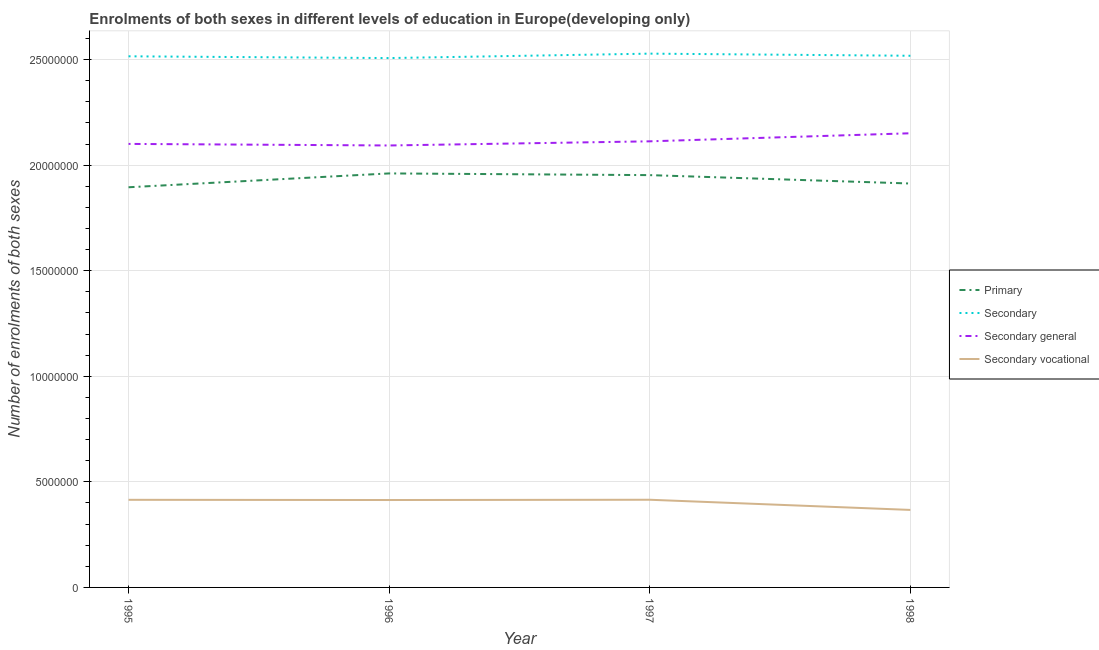How many different coloured lines are there?
Offer a terse response. 4. What is the number of enrolments in secondary education in 1998?
Keep it short and to the point. 2.52e+07. Across all years, what is the maximum number of enrolments in secondary education?
Your response must be concise. 2.53e+07. Across all years, what is the minimum number of enrolments in secondary education?
Offer a terse response. 2.51e+07. What is the total number of enrolments in secondary vocational education in the graph?
Offer a terse response. 1.61e+07. What is the difference between the number of enrolments in primary education in 1996 and that in 1997?
Provide a succinct answer. 8.08e+04. What is the difference between the number of enrolments in primary education in 1998 and the number of enrolments in secondary general education in 1995?
Your response must be concise. -1.88e+06. What is the average number of enrolments in primary education per year?
Your answer should be very brief. 1.93e+07. In the year 1995, what is the difference between the number of enrolments in secondary general education and number of enrolments in secondary education?
Your response must be concise. -4.15e+06. In how many years, is the number of enrolments in secondary general education greater than 15000000?
Your answer should be very brief. 4. What is the ratio of the number of enrolments in primary education in 1995 to that in 1997?
Keep it short and to the point. 0.97. Is the difference between the number of enrolments in secondary vocational education in 1996 and 1997 greater than the difference between the number of enrolments in primary education in 1996 and 1997?
Provide a short and direct response. No. What is the difference between the highest and the second highest number of enrolments in secondary general education?
Your answer should be compact. 3.82e+05. What is the difference between the highest and the lowest number of enrolments in primary education?
Offer a terse response. 6.56e+05. Does the number of enrolments in primary education monotonically increase over the years?
Make the answer very short. No. Is the number of enrolments in secondary vocational education strictly less than the number of enrolments in secondary education over the years?
Keep it short and to the point. Yes. How many years are there in the graph?
Give a very brief answer. 4. Are the values on the major ticks of Y-axis written in scientific E-notation?
Your answer should be compact. No. Does the graph contain any zero values?
Your response must be concise. No. Where does the legend appear in the graph?
Your response must be concise. Center right. How are the legend labels stacked?
Your answer should be very brief. Vertical. What is the title of the graph?
Offer a terse response. Enrolments of both sexes in different levels of education in Europe(developing only). Does "UNAIDS" appear as one of the legend labels in the graph?
Ensure brevity in your answer.  No. What is the label or title of the X-axis?
Provide a short and direct response. Year. What is the label or title of the Y-axis?
Provide a succinct answer. Number of enrolments of both sexes. What is the Number of enrolments of both sexes of Primary in 1995?
Your answer should be compact. 1.90e+07. What is the Number of enrolments of both sexes in Secondary in 1995?
Ensure brevity in your answer.  2.52e+07. What is the Number of enrolments of both sexes in Secondary general in 1995?
Give a very brief answer. 2.10e+07. What is the Number of enrolments of both sexes in Secondary vocational in 1995?
Offer a terse response. 4.15e+06. What is the Number of enrolments of both sexes of Primary in 1996?
Your answer should be compact. 1.96e+07. What is the Number of enrolments of both sexes of Secondary in 1996?
Your response must be concise. 2.51e+07. What is the Number of enrolments of both sexes in Secondary general in 1996?
Give a very brief answer. 2.09e+07. What is the Number of enrolments of both sexes of Secondary vocational in 1996?
Offer a very short reply. 4.14e+06. What is the Number of enrolments of both sexes of Primary in 1997?
Provide a short and direct response. 1.95e+07. What is the Number of enrolments of both sexes of Secondary in 1997?
Provide a short and direct response. 2.53e+07. What is the Number of enrolments of both sexes of Secondary general in 1997?
Make the answer very short. 2.11e+07. What is the Number of enrolments of both sexes of Secondary vocational in 1997?
Ensure brevity in your answer.  4.15e+06. What is the Number of enrolments of both sexes in Primary in 1998?
Offer a terse response. 1.91e+07. What is the Number of enrolments of both sexes of Secondary in 1998?
Your answer should be compact. 2.52e+07. What is the Number of enrolments of both sexes of Secondary general in 1998?
Keep it short and to the point. 2.15e+07. What is the Number of enrolments of both sexes of Secondary vocational in 1998?
Keep it short and to the point. 3.67e+06. Across all years, what is the maximum Number of enrolments of both sexes of Primary?
Ensure brevity in your answer.  1.96e+07. Across all years, what is the maximum Number of enrolments of both sexes in Secondary?
Provide a short and direct response. 2.53e+07. Across all years, what is the maximum Number of enrolments of both sexes of Secondary general?
Make the answer very short. 2.15e+07. Across all years, what is the maximum Number of enrolments of both sexes of Secondary vocational?
Your answer should be compact. 4.15e+06. Across all years, what is the minimum Number of enrolments of both sexes of Primary?
Provide a succinct answer. 1.90e+07. Across all years, what is the minimum Number of enrolments of both sexes in Secondary?
Offer a terse response. 2.51e+07. Across all years, what is the minimum Number of enrolments of both sexes of Secondary general?
Your answer should be compact. 2.09e+07. Across all years, what is the minimum Number of enrolments of both sexes in Secondary vocational?
Keep it short and to the point. 3.67e+06. What is the total Number of enrolments of both sexes of Primary in the graph?
Your response must be concise. 7.72e+07. What is the total Number of enrolments of both sexes of Secondary in the graph?
Provide a short and direct response. 1.01e+08. What is the total Number of enrolments of both sexes in Secondary general in the graph?
Provide a short and direct response. 8.46e+07. What is the total Number of enrolments of both sexes in Secondary vocational in the graph?
Provide a succinct answer. 1.61e+07. What is the difference between the Number of enrolments of both sexes of Primary in 1995 and that in 1996?
Offer a very short reply. -6.56e+05. What is the difference between the Number of enrolments of both sexes of Secondary in 1995 and that in 1996?
Your answer should be very brief. 8.40e+04. What is the difference between the Number of enrolments of both sexes in Secondary general in 1995 and that in 1996?
Provide a short and direct response. 7.43e+04. What is the difference between the Number of enrolments of both sexes of Secondary vocational in 1995 and that in 1996?
Ensure brevity in your answer.  9676. What is the difference between the Number of enrolments of both sexes of Primary in 1995 and that in 1997?
Your answer should be compact. -5.75e+05. What is the difference between the Number of enrolments of both sexes of Secondary in 1995 and that in 1997?
Provide a short and direct response. -1.26e+05. What is the difference between the Number of enrolments of both sexes of Secondary general in 1995 and that in 1997?
Your answer should be compact. -1.22e+05. What is the difference between the Number of enrolments of both sexes of Secondary vocational in 1995 and that in 1997?
Your response must be concise. -3466.75. What is the difference between the Number of enrolments of both sexes of Primary in 1995 and that in 1998?
Your answer should be compact. -1.78e+05. What is the difference between the Number of enrolments of both sexes in Secondary in 1995 and that in 1998?
Your answer should be compact. -2.55e+04. What is the difference between the Number of enrolments of both sexes of Secondary general in 1995 and that in 1998?
Keep it short and to the point. -5.04e+05. What is the difference between the Number of enrolments of both sexes of Secondary vocational in 1995 and that in 1998?
Offer a very short reply. 4.79e+05. What is the difference between the Number of enrolments of both sexes of Primary in 1996 and that in 1997?
Your answer should be very brief. 8.08e+04. What is the difference between the Number of enrolments of both sexes of Secondary in 1996 and that in 1997?
Provide a short and direct response. -2.10e+05. What is the difference between the Number of enrolments of both sexes in Secondary general in 1996 and that in 1997?
Keep it short and to the point. -1.97e+05. What is the difference between the Number of enrolments of both sexes of Secondary vocational in 1996 and that in 1997?
Give a very brief answer. -1.31e+04. What is the difference between the Number of enrolments of both sexes of Primary in 1996 and that in 1998?
Keep it short and to the point. 4.78e+05. What is the difference between the Number of enrolments of both sexes of Secondary in 1996 and that in 1998?
Offer a very short reply. -1.09e+05. What is the difference between the Number of enrolments of both sexes in Secondary general in 1996 and that in 1998?
Provide a short and direct response. -5.78e+05. What is the difference between the Number of enrolments of both sexes in Secondary vocational in 1996 and that in 1998?
Give a very brief answer. 4.69e+05. What is the difference between the Number of enrolments of both sexes in Primary in 1997 and that in 1998?
Your response must be concise. 3.97e+05. What is the difference between the Number of enrolments of both sexes in Secondary in 1997 and that in 1998?
Make the answer very short. 1.00e+05. What is the difference between the Number of enrolments of both sexes in Secondary general in 1997 and that in 1998?
Your response must be concise. -3.82e+05. What is the difference between the Number of enrolments of both sexes of Secondary vocational in 1997 and that in 1998?
Provide a short and direct response. 4.82e+05. What is the difference between the Number of enrolments of both sexes of Primary in 1995 and the Number of enrolments of both sexes of Secondary in 1996?
Offer a terse response. -6.12e+06. What is the difference between the Number of enrolments of both sexes of Primary in 1995 and the Number of enrolments of both sexes of Secondary general in 1996?
Ensure brevity in your answer.  -1.98e+06. What is the difference between the Number of enrolments of both sexes in Primary in 1995 and the Number of enrolments of both sexes in Secondary vocational in 1996?
Offer a very short reply. 1.48e+07. What is the difference between the Number of enrolments of both sexes of Secondary in 1995 and the Number of enrolments of both sexes of Secondary general in 1996?
Provide a succinct answer. 4.22e+06. What is the difference between the Number of enrolments of both sexes in Secondary in 1995 and the Number of enrolments of both sexes in Secondary vocational in 1996?
Give a very brief answer. 2.10e+07. What is the difference between the Number of enrolments of both sexes in Secondary general in 1995 and the Number of enrolments of both sexes in Secondary vocational in 1996?
Keep it short and to the point. 1.69e+07. What is the difference between the Number of enrolments of both sexes in Primary in 1995 and the Number of enrolments of both sexes in Secondary in 1997?
Keep it short and to the point. -6.33e+06. What is the difference between the Number of enrolments of both sexes in Primary in 1995 and the Number of enrolments of both sexes in Secondary general in 1997?
Your answer should be very brief. -2.18e+06. What is the difference between the Number of enrolments of both sexes of Primary in 1995 and the Number of enrolments of both sexes of Secondary vocational in 1997?
Offer a terse response. 1.48e+07. What is the difference between the Number of enrolments of both sexes of Secondary in 1995 and the Number of enrolments of both sexes of Secondary general in 1997?
Keep it short and to the point. 4.03e+06. What is the difference between the Number of enrolments of both sexes of Secondary in 1995 and the Number of enrolments of both sexes of Secondary vocational in 1997?
Your answer should be very brief. 2.10e+07. What is the difference between the Number of enrolments of both sexes of Secondary general in 1995 and the Number of enrolments of both sexes of Secondary vocational in 1997?
Provide a short and direct response. 1.69e+07. What is the difference between the Number of enrolments of both sexes in Primary in 1995 and the Number of enrolments of both sexes in Secondary in 1998?
Provide a short and direct response. -6.23e+06. What is the difference between the Number of enrolments of both sexes in Primary in 1995 and the Number of enrolments of both sexes in Secondary general in 1998?
Provide a succinct answer. -2.56e+06. What is the difference between the Number of enrolments of both sexes in Primary in 1995 and the Number of enrolments of both sexes in Secondary vocational in 1998?
Give a very brief answer. 1.53e+07. What is the difference between the Number of enrolments of both sexes in Secondary in 1995 and the Number of enrolments of both sexes in Secondary general in 1998?
Offer a very short reply. 3.65e+06. What is the difference between the Number of enrolments of both sexes of Secondary in 1995 and the Number of enrolments of both sexes of Secondary vocational in 1998?
Provide a succinct answer. 2.15e+07. What is the difference between the Number of enrolments of both sexes of Secondary general in 1995 and the Number of enrolments of both sexes of Secondary vocational in 1998?
Give a very brief answer. 1.73e+07. What is the difference between the Number of enrolments of both sexes in Primary in 1996 and the Number of enrolments of both sexes in Secondary in 1997?
Give a very brief answer. -5.67e+06. What is the difference between the Number of enrolments of both sexes in Primary in 1996 and the Number of enrolments of both sexes in Secondary general in 1997?
Provide a short and direct response. -1.52e+06. What is the difference between the Number of enrolments of both sexes in Primary in 1996 and the Number of enrolments of both sexes in Secondary vocational in 1997?
Your answer should be compact. 1.55e+07. What is the difference between the Number of enrolments of both sexes in Secondary in 1996 and the Number of enrolments of both sexes in Secondary general in 1997?
Make the answer very short. 3.94e+06. What is the difference between the Number of enrolments of both sexes of Secondary in 1996 and the Number of enrolments of both sexes of Secondary vocational in 1997?
Ensure brevity in your answer.  2.09e+07. What is the difference between the Number of enrolments of both sexes of Secondary general in 1996 and the Number of enrolments of both sexes of Secondary vocational in 1997?
Offer a terse response. 1.68e+07. What is the difference between the Number of enrolments of both sexes in Primary in 1996 and the Number of enrolments of both sexes in Secondary in 1998?
Ensure brevity in your answer.  -5.57e+06. What is the difference between the Number of enrolments of both sexes in Primary in 1996 and the Number of enrolments of both sexes in Secondary general in 1998?
Ensure brevity in your answer.  -1.90e+06. What is the difference between the Number of enrolments of both sexes of Primary in 1996 and the Number of enrolments of both sexes of Secondary vocational in 1998?
Offer a very short reply. 1.59e+07. What is the difference between the Number of enrolments of both sexes of Secondary in 1996 and the Number of enrolments of both sexes of Secondary general in 1998?
Make the answer very short. 3.56e+06. What is the difference between the Number of enrolments of both sexes in Secondary in 1996 and the Number of enrolments of both sexes in Secondary vocational in 1998?
Give a very brief answer. 2.14e+07. What is the difference between the Number of enrolments of both sexes of Secondary general in 1996 and the Number of enrolments of both sexes of Secondary vocational in 1998?
Ensure brevity in your answer.  1.73e+07. What is the difference between the Number of enrolments of both sexes of Primary in 1997 and the Number of enrolments of both sexes of Secondary in 1998?
Make the answer very short. -5.65e+06. What is the difference between the Number of enrolments of both sexes of Primary in 1997 and the Number of enrolments of both sexes of Secondary general in 1998?
Keep it short and to the point. -1.98e+06. What is the difference between the Number of enrolments of both sexes of Primary in 1997 and the Number of enrolments of both sexes of Secondary vocational in 1998?
Offer a very short reply. 1.59e+07. What is the difference between the Number of enrolments of both sexes in Secondary in 1997 and the Number of enrolments of both sexes in Secondary general in 1998?
Your answer should be very brief. 3.77e+06. What is the difference between the Number of enrolments of both sexes of Secondary in 1997 and the Number of enrolments of both sexes of Secondary vocational in 1998?
Your response must be concise. 2.16e+07. What is the difference between the Number of enrolments of both sexes in Secondary general in 1997 and the Number of enrolments of both sexes in Secondary vocational in 1998?
Your answer should be very brief. 1.75e+07. What is the average Number of enrolments of both sexes in Primary per year?
Your answer should be very brief. 1.93e+07. What is the average Number of enrolments of both sexes in Secondary per year?
Your answer should be very brief. 2.52e+07. What is the average Number of enrolments of both sexes of Secondary general per year?
Ensure brevity in your answer.  2.11e+07. What is the average Number of enrolments of both sexes of Secondary vocational per year?
Offer a very short reply. 4.03e+06. In the year 1995, what is the difference between the Number of enrolments of both sexes in Primary and Number of enrolments of both sexes in Secondary?
Provide a short and direct response. -6.20e+06. In the year 1995, what is the difference between the Number of enrolments of both sexes of Primary and Number of enrolments of both sexes of Secondary general?
Make the answer very short. -2.05e+06. In the year 1995, what is the difference between the Number of enrolments of both sexes in Primary and Number of enrolments of both sexes in Secondary vocational?
Your answer should be very brief. 1.48e+07. In the year 1995, what is the difference between the Number of enrolments of both sexes of Secondary and Number of enrolments of both sexes of Secondary general?
Your response must be concise. 4.15e+06. In the year 1995, what is the difference between the Number of enrolments of both sexes of Secondary and Number of enrolments of both sexes of Secondary vocational?
Give a very brief answer. 2.10e+07. In the year 1995, what is the difference between the Number of enrolments of both sexes of Secondary general and Number of enrolments of both sexes of Secondary vocational?
Your answer should be compact. 1.69e+07. In the year 1996, what is the difference between the Number of enrolments of both sexes in Primary and Number of enrolments of both sexes in Secondary?
Your answer should be very brief. -5.46e+06. In the year 1996, what is the difference between the Number of enrolments of both sexes in Primary and Number of enrolments of both sexes in Secondary general?
Make the answer very short. -1.32e+06. In the year 1996, what is the difference between the Number of enrolments of both sexes of Primary and Number of enrolments of both sexes of Secondary vocational?
Offer a terse response. 1.55e+07. In the year 1996, what is the difference between the Number of enrolments of both sexes of Secondary and Number of enrolments of both sexes of Secondary general?
Offer a terse response. 4.14e+06. In the year 1996, what is the difference between the Number of enrolments of both sexes of Secondary and Number of enrolments of both sexes of Secondary vocational?
Provide a succinct answer. 2.09e+07. In the year 1996, what is the difference between the Number of enrolments of both sexes of Secondary general and Number of enrolments of both sexes of Secondary vocational?
Give a very brief answer. 1.68e+07. In the year 1997, what is the difference between the Number of enrolments of both sexes of Primary and Number of enrolments of both sexes of Secondary?
Keep it short and to the point. -5.75e+06. In the year 1997, what is the difference between the Number of enrolments of both sexes of Primary and Number of enrolments of both sexes of Secondary general?
Your answer should be compact. -1.60e+06. In the year 1997, what is the difference between the Number of enrolments of both sexes of Primary and Number of enrolments of both sexes of Secondary vocational?
Provide a succinct answer. 1.54e+07. In the year 1997, what is the difference between the Number of enrolments of both sexes of Secondary and Number of enrolments of both sexes of Secondary general?
Ensure brevity in your answer.  4.15e+06. In the year 1997, what is the difference between the Number of enrolments of both sexes of Secondary and Number of enrolments of both sexes of Secondary vocational?
Ensure brevity in your answer.  2.11e+07. In the year 1997, what is the difference between the Number of enrolments of both sexes in Secondary general and Number of enrolments of both sexes in Secondary vocational?
Offer a very short reply. 1.70e+07. In the year 1998, what is the difference between the Number of enrolments of both sexes of Primary and Number of enrolments of both sexes of Secondary?
Keep it short and to the point. -6.05e+06. In the year 1998, what is the difference between the Number of enrolments of both sexes in Primary and Number of enrolments of both sexes in Secondary general?
Ensure brevity in your answer.  -2.38e+06. In the year 1998, what is the difference between the Number of enrolments of both sexes of Primary and Number of enrolments of both sexes of Secondary vocational?
Your response must be concise. 1.55e+07. In the year 1998, what is the difference between the Number of enrolments of both sexes in Secondary and Number of enrolments of both sexes in Secondary general?
Offer a terse response. 3.67e+06. In the year 1998, what is the difference between the Number of enrolments of both sexes of Secondary and Number of enrolments of both sexes of Secondary vocational?
Offer a terse response. 2.15e+07. In the year 1998, what is the difference between the Number of enrolments of both sexes of Secondary general and Number of enrolments of both sexes of Secondary vocational?
Offer a terse response. 1.78e+07. What is the ratio of the Number of enrolments of both sexes in Primary in 1995 to that in 1996?
Your response must be concise. 0.97. What is the ratio of the Number of enrolments of both sexes in Secondary general in 1995 to that in 1996?
Give a very brief answer. 1. What is the ratio of the Number of enrolments of both sexes of Secondary vocational in 1995 to that in 1996?
Ensure brevity in your answer.  1. What is the ratio of the Number of enrolments of both sexes in Primary in 1995 to that in 1997?
Keep it short and to the point. 0.97. What is the ratio of the Number of enrolments of both sexes of Secondary in 1995 to that in 1997?
Provide a short and direct response. 0.99. What is the ratio of the Number of enrolments of both sexes in Secondary vocational in 1995 to that in 1997?
Keep it short and to the point. 1. What is the ratio of the Number of enrolments of both sexes of Primary in 1995 to that in 1998?
Your response must be concise. 0.99. What is the ratio of the Number of enrolments of both sexes of Secondary general in 1995 to that in 1998?
Provide a short and direct response. 0.98. What is the ratio of the Number of enrolments of both sexes in Secondary vocational in 1995 to that in 1998?
Give a very brief answer. 1.13. What is the ratio of the Number of enrolments of both sexes of Secondary in 1996 to that in 1997?
Make the answer very short. 0.99. What is the ratio of the Number of enrolments of both sexes in Secondary vocational in 1996 to that in 1997?
Ensure brevity in your answer.  1. What is the ratio of the Number of enrolments of both sexes in Secondary general in 1996 to that in 1998?
Offer a very short reply. 0.97. What is the ratio of the Number of enrolments of both sexes of Secondary vocational in 1996 to that in 1998?
Keep it short and to the point. 1.13. What is the ratio of the Number of enrolments of both sexes in Primary in 1997 to that in 1998?
Keep it short and to the point. 1.02. What is the ratio of the Number of enrolments of both sexes in Secondary in 1997 to that in 1998?
Your response must be concise. 1. What is the ratio of the Number of enrolments of both sexes in Secondary general in 1997 to that in 1998?
Provide a succinct answer. 0.98. What is the ratio of the Number of enrolments of both sexes in Secondary vocational in 1997 to that in 1998?
Provide a short and direct response. 1.13. What is the difference between the highest and the second highest Number of enrolments of both sexes in Primary?
Keep it short and to the point. 8.08e+04. What is the difference between the highest and the second highest Number of enrolments of both sexes of Secondary?
Your answer should be compact. 1.00e+05. What is the difference between the highest and the second highest Number of enrolments of both sexes of Secondary general?
Ensure brevity in your answer.  3.82e+05. What is the difference between the highest and the second highest Number of enrolments of both sexes in Secondary vocational?
Your response must be concise. 3466.75. What is the difference between the highest and the lowest Number of enrolments of both sexes of Primary?
Offer a very short reply. 6.56e+05. What is the difference between the highest and the lowest Number of enrolments of both sexes of Secondary?
Your answer should be very brief. 2.10e+05. What is the difference between the highest and the lowest Number of enrolments of both sexes in Secondary general?
Your answer should be very brief. 5.78e+05. What is the difference between the highest and the lowest Number of enrolments of both sexes of Secondary vocational?
Provide a succinct answer. 4.82e+05. 